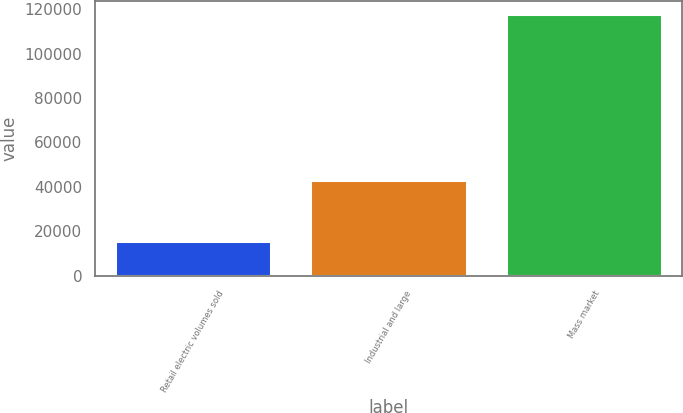Convert chart. <chart><loc_0><loc_0><loc_500><loc_500><bar_chart><fcel>Retail electric volumes sold<fcel>Industrial and large<fcel>Mass market<nl><fcel>15725<fcel>42983<fcel>117635<nl></chart> 